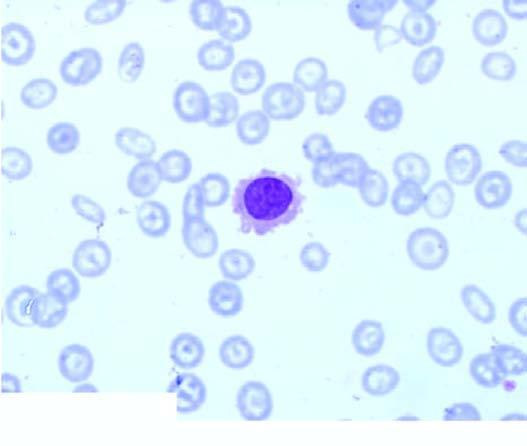what shows presence of a leukaemic cells with hairy cytoplasmic projections?
Answer the question using a single word or phrase. Peripheral blood 